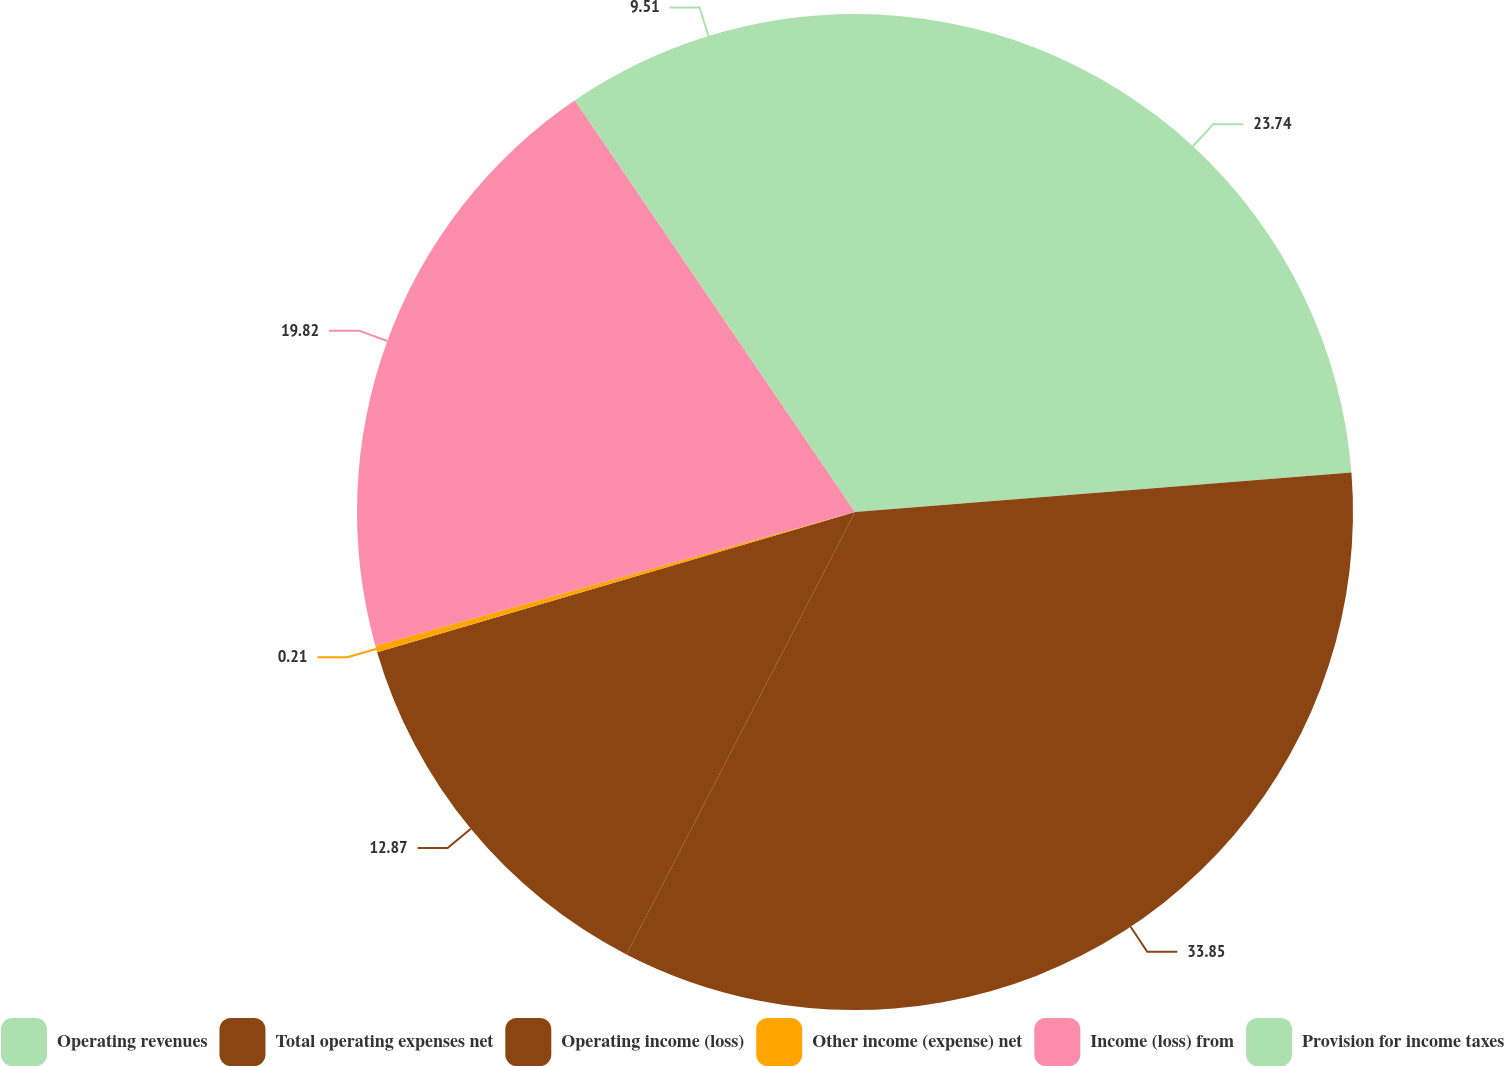Convert chart to OTSL. <chart><loc_0><loc_0><loc_500><loc_500><pie_chart><fcel>Operating revenues<fcel>Total operating expenses net<fcel>Operating income (loss)<fcel>Other income (expense) net<fcel>Income (loss) from<fcel>Provision for income taxes<nl><fcel>23.74%<fcel>33.85%<fcel>12.87%<fcel>0.21%<fcel>19.82%<fcel>9.51%<nl></chart> 